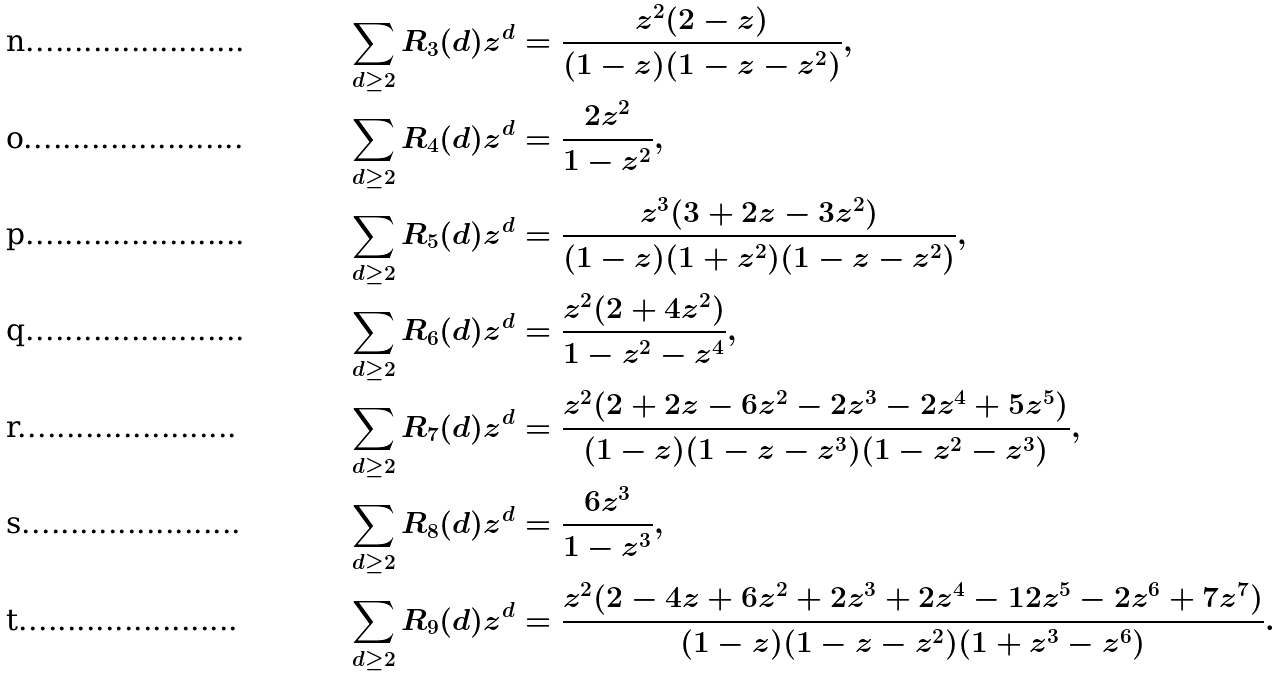Convert formula to latex. <formula><loc_0><loc_0><loc_500><loc_500>\sum _ { d \geq 2 } R _ { 3 } ( d ) z ^ { d } & = \frac { z ^ { 2 } ( 2 - z ) } { ( 1 - z ) ( 1 - z - z ^ { 2 } ) } , \\ \sum _ { d \geq 2 } R _ { 4 } ( d ) z ^ { d } & = \frac { 2 z ^ { 2 } } { 1 - z ^ { 2 } } , \\ \sum _ { d \geq 2 } R _ { 5 } ( d ) z ^ { d } & = \frac { z ^ { 3 } ( 3 + 2 z - 3 z ^ { 2 } ) } { ( 1 - z ) ( 1 + z ^ { 2 } ) ( 1 - z - z ^ { 2 } ) } , \\ \sum _ { d \geq 2 } R _ { 6 } ( d ) z ^ { d } & = \frac { z ^ { 2 } ( 2 + 4 z ^ { 2 } ) } { 1 - z ^ { 2 } - z ^ { 4 } } , \\ \sum _ { d \geq 2 } R _ { 7 } ( d ) z ^ { d } & = \frac { z ^ { 2 } ( 2 + 2 z - 6 z ^ { 2 } - 2 z ^ { 3 } - 2 z ^ { 4 } + 5 z ^ { 5 } ) } { ( 1 - z ) ( 1 - z - z ^ { 3 } ) ( 1 - z ^ { 2 } - z ^ { 3 } ) } , \\ \sum _ { d \geq 2 } R _ { 8 } ( d ) z ^ { d } & = \frac { 6 z ^ { 3 } } { 1 - z ^ { 3 } } , \\ \sum _ { d \geq 2 } R _ { 9 } ( d ) z ^ { d } & = \frac { z ^ { 2 } ( 2 - 4 z + 6 z ^ { 2 } + 2 z ^ { 3 } + 2 z ^ { 4 } - 1 2 z ^ { 5 } - 2 z ^ { 6 } + 7 z ^ { 7 } ) } { ( 1 - z ) ( 1 - z - z ^ { 2 } ) ( 1 + z ^ { 3 } - z ^ { 6 } ) } .</formula> 